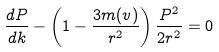<formula> <loc_0><loc_0><loc_500><loc_500>\frac { d P } { d k } - \left ( 1 - \frac { 3 m ( v ) } { r ^ { 2 } } \right ) \frac { P ^ { 2 } } { 2 r ^ { 2 } } = 0</formula> 